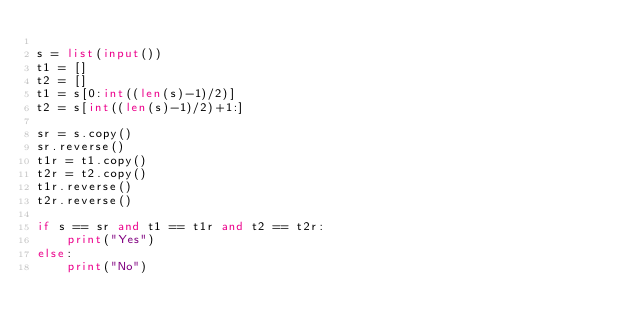<code> <loc_0><loc_0><loc_500><loc_500><_Python_>
s = list(input())
t1 = []
t2 = []
t1 = s[0:int((len(s)-1)/2)]
t2 = s[int((len(s)-1)/2)+1:]

sr = s.copy()
sr.reverse()
t1r = t1.copy()
t2r = t2.copy()
t1r.reverse()
t2r.reverse()

if s == sr and t1 == t1r and t2 == t2r:
    print("Yes")
else:
    print("No")
</code> 